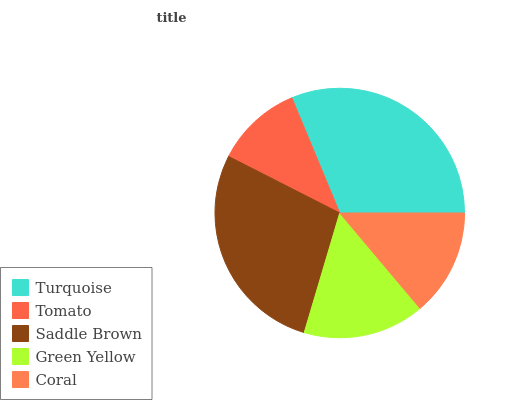Is Tomato the minimum?
Answer yes or no. Yes. Is Turquoise the maximum?
Answer yes or no. Yes. Is Saddle Brown the minimum?
Answer yes or no. No. Is Saddle Brown the maximum?
Answer yes or no. No. Is Saddle Brown greater than Tomato?
Answer yes or no. Yes. Is Tomato less than Saddle Brown?
Answer yes or no. Yes. Is Tomato greater than Saddle Brown?
Answer yes or no. No. Is Saddle Brown less than Tomato?
Answer yes or no. No. Is Green Yellow the high median?
Answer yes or no. Yes. Is Green Yellow the low median?
Answer yes or no. Yes. Is Coral the high median?
Answer yes or no. No. Is Tomato the low median?
Answer yes or no. No. 